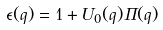Convert formula to latex. <formula><loc_0><loc_0><loc_500><loc_500>\epsilon ( { q } ) = 1 + U _ { 0 } ( q ) \Pi ( { q } )</formula> 